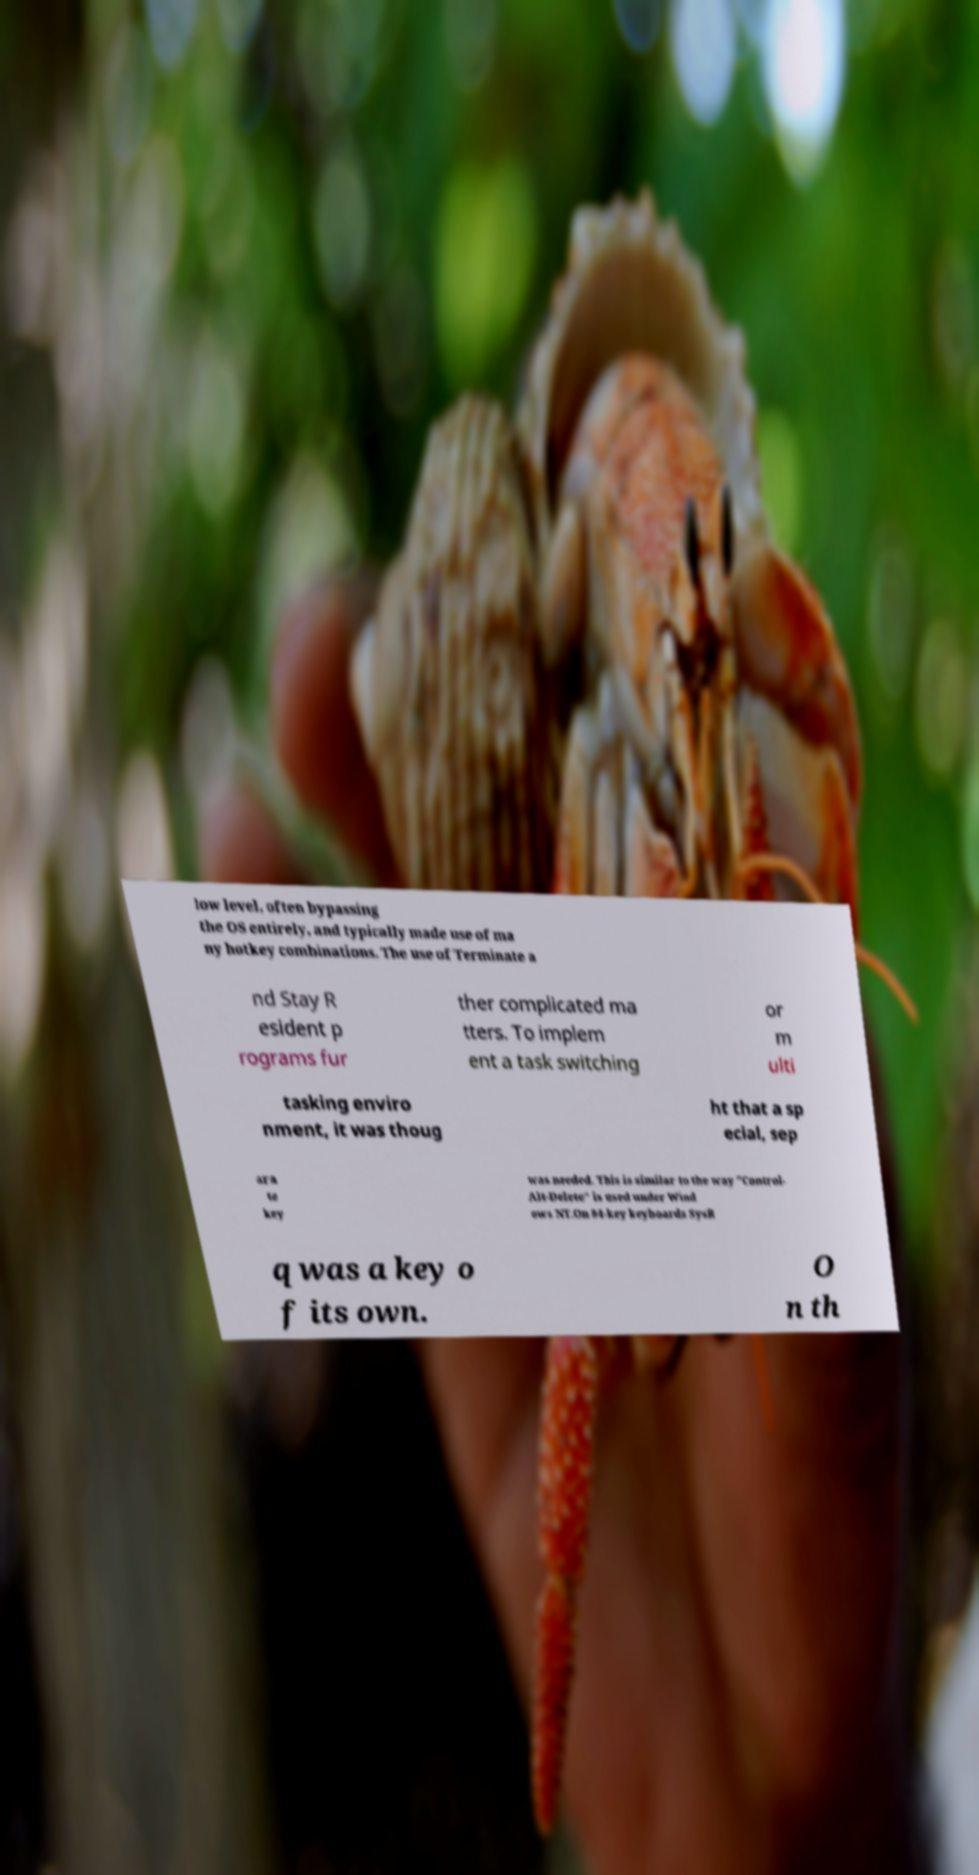Please identify and transcribe the text found in this image. low level, often bypassing the OS entirely, and typically made use of ma ny hotkey combinations. The use of Terminate a nd Stay R esident p rograms fur ther complicated ma tters. To implem ent a task switching or m ulti tasking enviro nment, it was thoug ht that a sp ecial, sep ara te key was needed. This is similar to the way "Control- Alt-Delete" is used under Wind ows NT.On 84-key keyboards SysR q was a key o f its own. O n th 